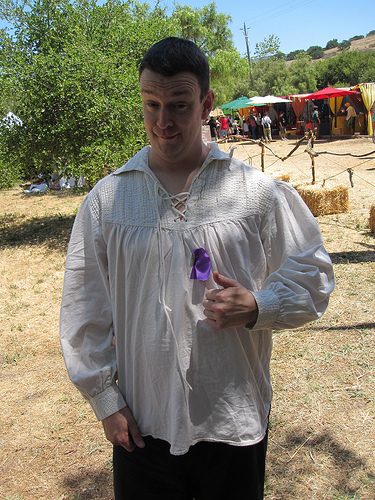<image>
Is there a ribbon on the shirt? Yes. Looking at the image, I can see the ribbon is positioned on top of the shirt, with the shirt providing support. Is there a post in the ground? No. The post is not contained within the ground. These objects have a different spatial relationship. 